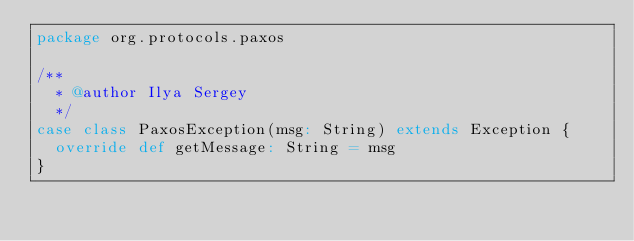Convert code to text. <code><loc_0><loc_0><loc_500><loc_500><_Scala_>package org.protocols.paxos

/**
  * @author Ilya Sergey
  */
case class PaxosException(msg: String) extends Exception {
  override def getMessage: String = msg
}</code> 